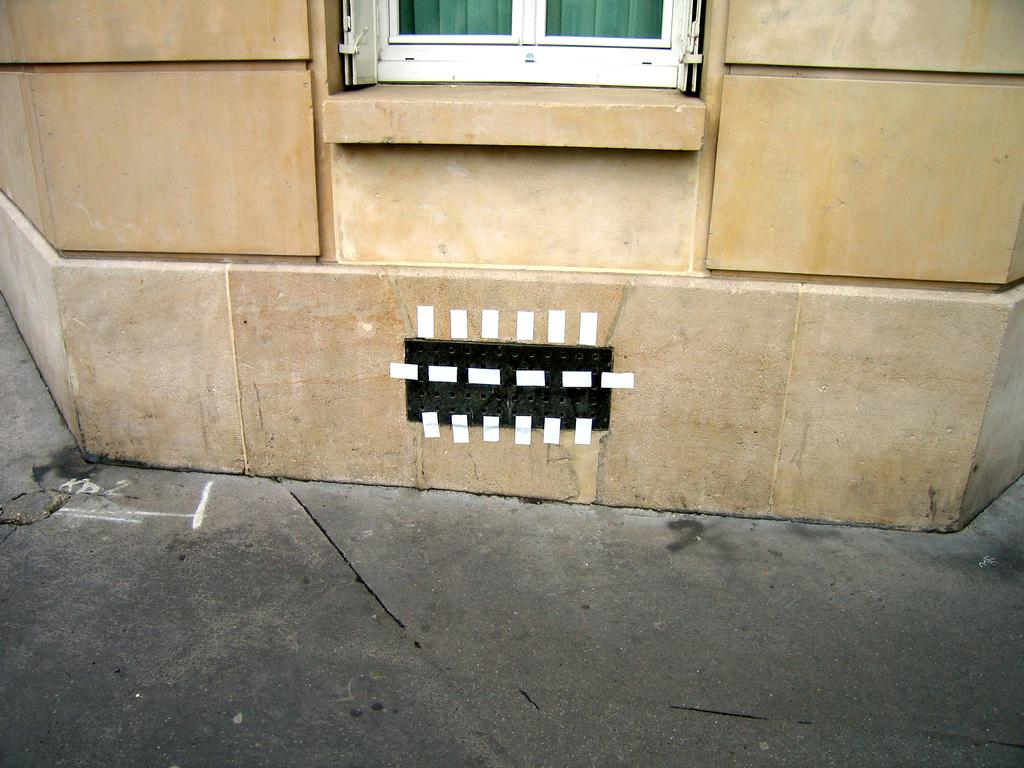What type of pathway is visible in the image? There is a road in the image. What structure can be seen alongside the road? There is a wall in the image. Is there any opening in the wall that allows for visibility? Yes, there is a window in the image. What type of steel structure can be seen in the image? There is no steel structure present in the image. Can you describe the van that is parked near the wall in the image? There is no van present in the image; only a road, wall, and window are visible. 